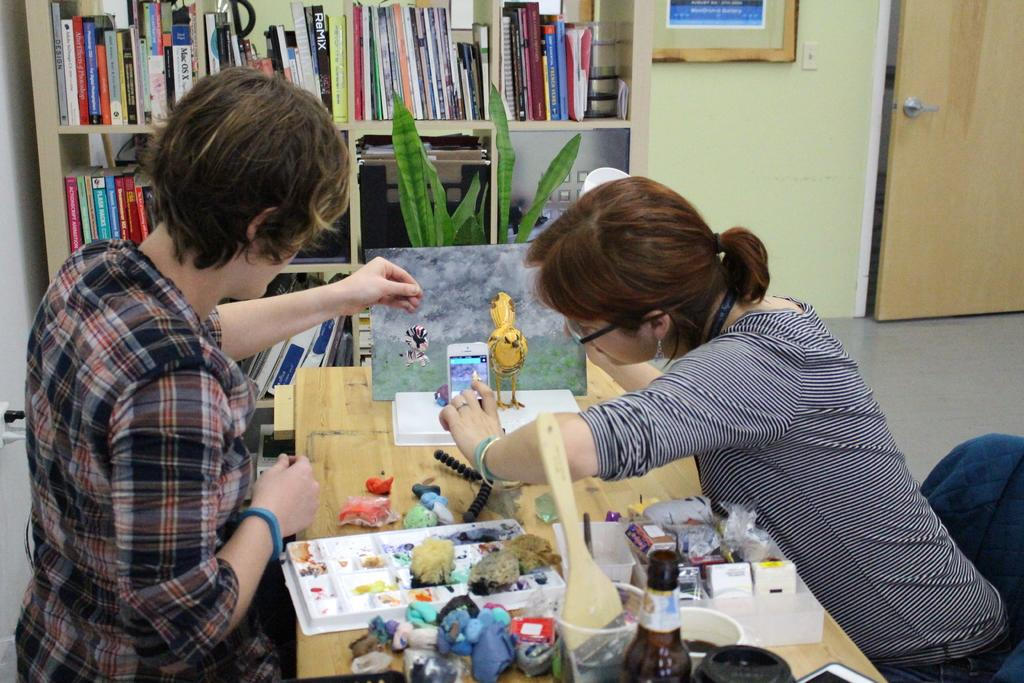How many women are present in the image? There are two women standing in the image. What can be seen on a shelf in the image? There are books in a shelf in a shelf in the image. What type of container is visible in the image? There is a bottle and a cup in the image. What electronic device is present in the image? There is a phone in the image. What other objects can be seen on a table in the image? There are other objects on a table in the image. What architectural feature is present in the image? There is a door in the image. What type of thought is visible in the image? There are no thoughts visible in the image; it is a photograph and does not depict mental processes or ideas. 